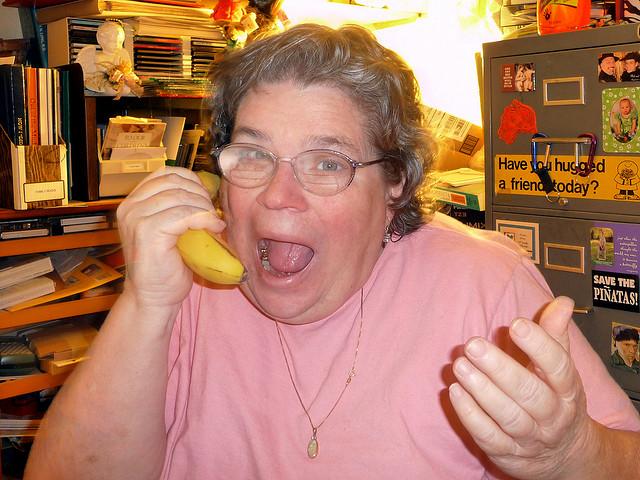How many bananas are there?
Answer briefly. 1. What is the woman holding?
Answer briefly. Banana. Is the yellow thing she is holding up to her ear a telephone?
Quick response, please. No. Is the woman funny?
Write a very short answer. Yes. 